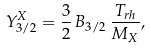Convert formula to latex. <formula><loc_0><loc_0><loc_500><loc_500>Y _ { 3 / 2 } ^ { X } = \frac { 3 } { 2 } \, B _ { 3 / 2 } \, \frac { T _ { r h } } { M _ { X } } ,</formula> 